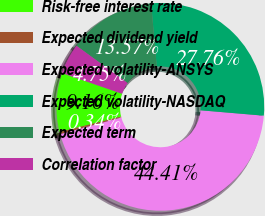Convert chart to OTSL. <chart><loc_0><loc_0><loc_500><loc_500><pie_chart><fcel>Risk-free interest rate<fcel>Expected dividend yield<fcel>Expected volatility-ANSYS<fcel>Expected volatility-NASDAQ<fcel>Expected term<fcel>Correlation factor<nl><fcel>9.16%<fcel>0.34%<fcel>44.41%<fcel>27.76%<fcel>13.57%<fcel>4.75%<nl></chart> 